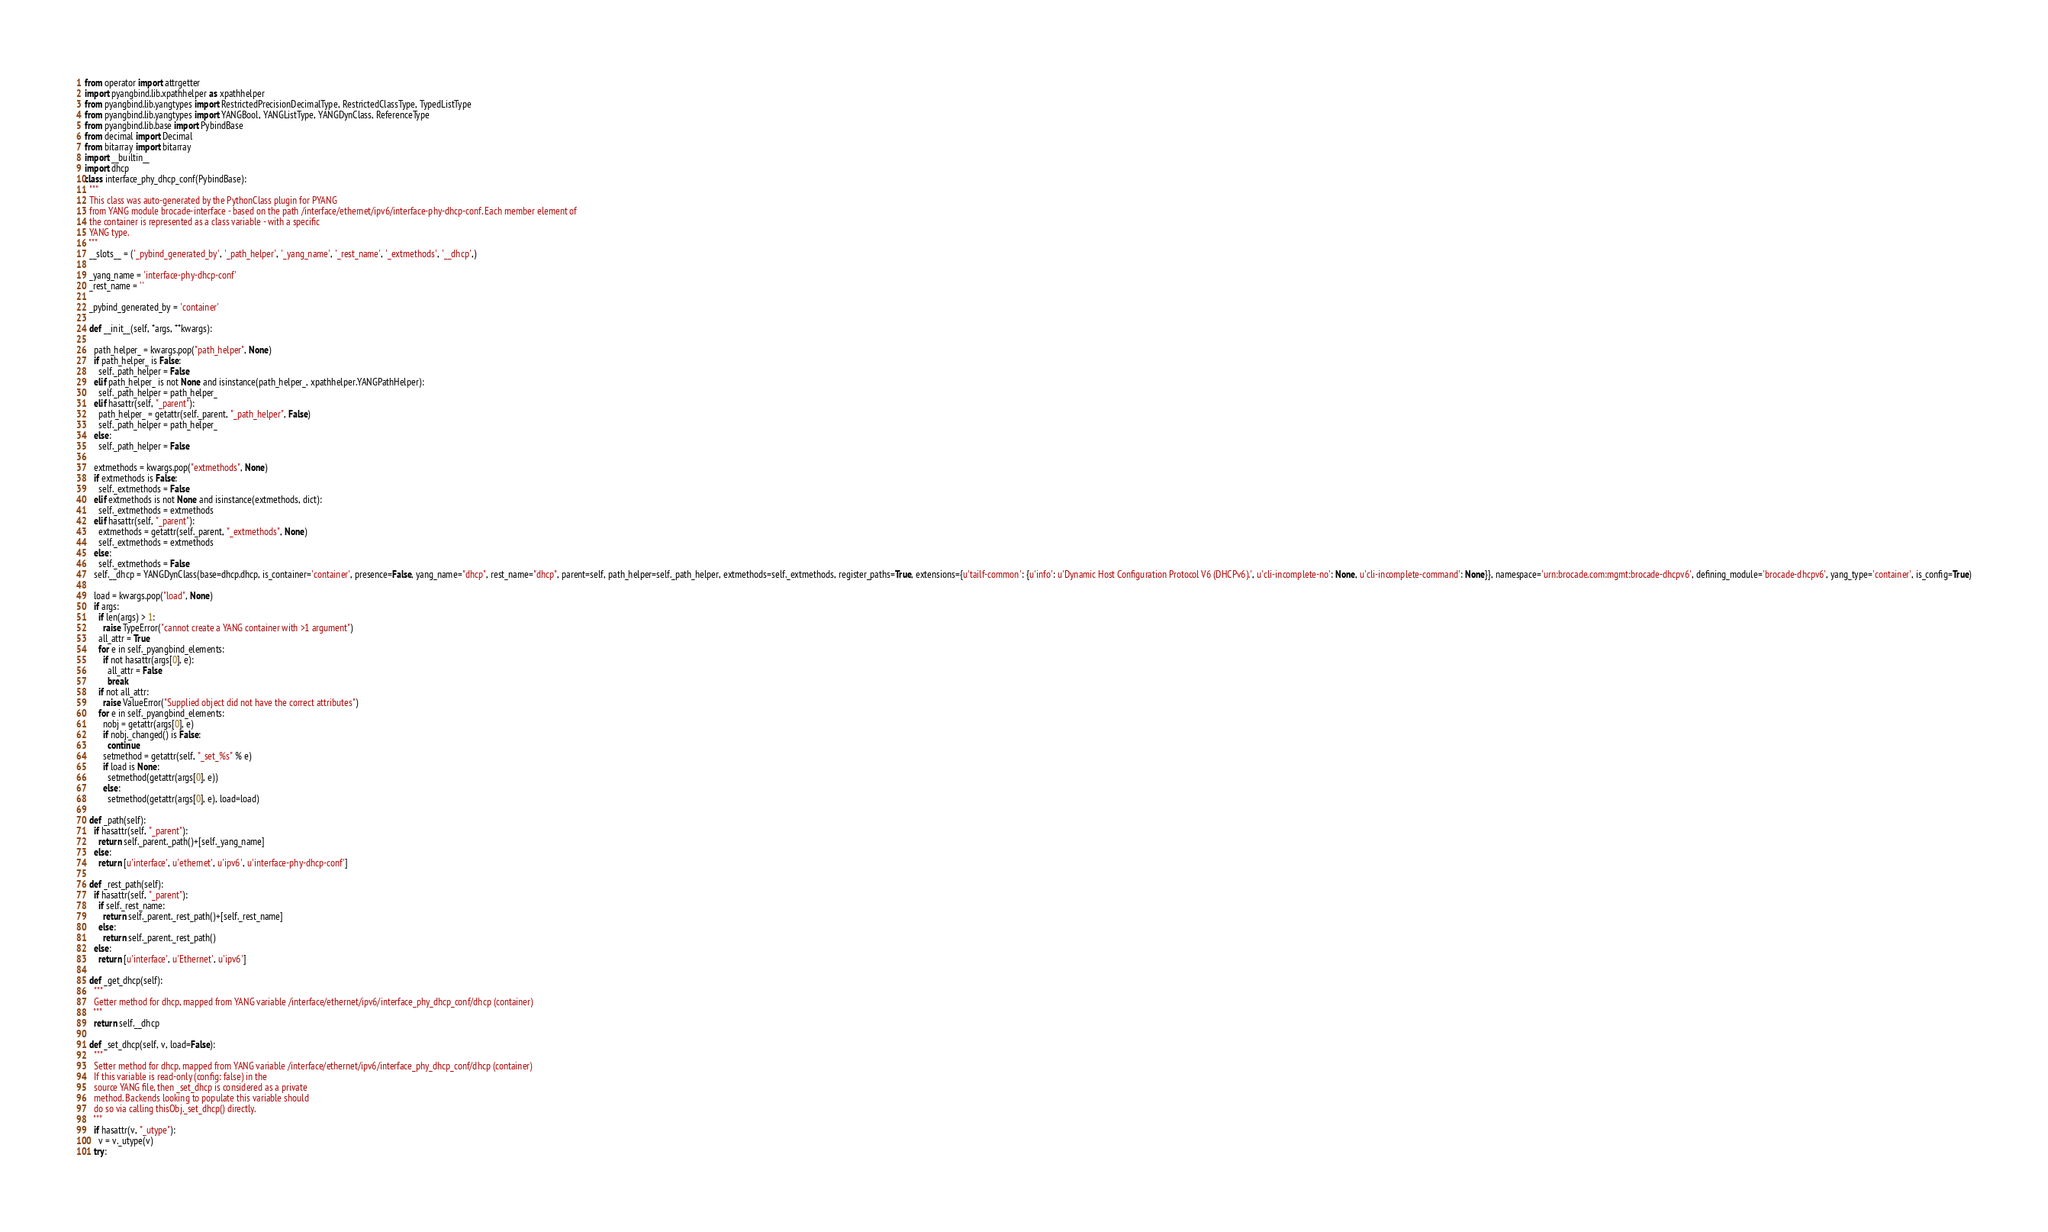Convert code to text. <code><loc_0><loc_0><loc_500><loc_500><_Python_>
from operator import attrgetter
import pyangbind.lib.xpathhelper as xpathhelper
from pyangbind.lib.yangtypes import RestrictedPrecisionDecimalType, RestrictedClassType, TypedListType
from pyangbind.lib.yangtypes import YANGBool, YANGListType, YANGDynClass, ReferenceType
from pyangbind.lib.base import PybindBase
from decimal import Decimal
from bitarray import bitarray
import __builtin__
import dhcp
class interface_phy_dhcp_conf(PybindBase):
  """
  This class was auto-generated by the PythonClass plugin for PYANG
  from YANG module brocade-interface - based on the path /interface/ethernet/ipv6/interface-phy-dhcp-conf. Each member element of
  the container is represented as a class variable - with a specific
  YANG type.
  """
  __slots__ = ('_pybind_generated_by', '_path_helper', '_yang_name', '_rest_name', '_extmethods', '__dhcp',)

  _yang_name = 'interface-phy-dhcp-conf'
  _rest_name = ''

  _pybind_generated_by = 'container'

  def __init__(self, *args, **kwargs):

    path_helper_ = kwargs.pop("path_helper", None)
    if path_helper_ is False:
      self._path_helper = False
    elif path_helper_ is not None and isinstance(path_helper_, xpathhelper.YANGPathHelper):
      self._path_helper = path_helper_
    elif hasattr(self, "_parent"):
      path_helper_ = getattr(self._parent, "_path_helper", False)
      self._path_helper = path_helper_
    else:
      self._path_helper = False

    extmethods = kwargs.pop("extmethods", None)
    if extmethods is False:
      self._extmethods = False
    elif extmethods is not None and isinstance(extmethods, dict):
      self._extmethods = extmethods
    elif hasattr(self, "_parent"):
      extmethods = getattr(self._parent, "_extmethods", None)
      self._extmethods = extmethods
    else:
      self._extmethods = False
    self.__dhcp = YANGDynClass(base=dhcp.dhcp, is_container='container', presence=False, yang_name="dhcp", rest_name="dhcp", parent=self, path_helper=self._path_helper, extmethods=self._extmethods, register_paths=True, extensions={u'tailf-common': {u'info': u'Dynamic Host Configuration Protocol V6 (DHCPv6).', u'cli-incomplete-no': None, u'cli-incomplete-command': None}}, namespace='urn:brocade.com:mgmt:brocade-dhcpv6', defining_module='brocade-dhcpv6', yang_type='container', is_config=True)

    load = kwargs.pop("load", None)
    if args:
      if len(args) > 1:
        raise TypeError("cannot create a YANG container with >1 argument")
      all_attr = True
      for e in self._pyangbind_elements:
        if not hasattr(args[0], e):
          all_attr = False
          break
      if not all_attr:
        raise ValueError("Supplied object did not have the correct attributes")
      for e in self._pyangbind_elements:
        nobj = getattr(args[0], e)
        if nobj._changed() is False:
          continue
        setmethod = getattr(self, "_set_%s" % e)
        if load is None:
          setmethod(getattr(args[0], e))
        else:
          setmethod(getattr(args[0], e), load=load)

  def _path(self):
    if hasattr(self, "_parent"):
      return self._parent._path()+[self._yang_name]
    else:
      return [u'interface', u'ethernet', u'ipv6', u'interface-phy-dhcp-conf']

  def _rest_path(self):
    if hasattr(self, "_parent"):
      if self._rest_name:
        return self._parent._rest_path()+[self._rest_name]
      else:
        return self._parent._rest_path()
    else:
      return [u'interface', u'Ethernet', u'ipv6']

  def _get_dhcp(self):
    """
    Getter method for dhcp, mapped from YANG variable /interface/ethernet/ipv6/interface_phy_dhcp_conf/dhcp (container)
    """
    return self.__dhcp
      
  def _set_dhcp(self, v, load=False):
    """
    Setter method for dhcp, mapped from YANG variable /interface/ethernet/ipv6/interface_phy_dhcp_conf/dhcp (container)
    If this variable is read-only (config: false) in the
    source YANG file, then _set_dhcp is considered as a private
    method. Backends looking to populate this variable should
    do so via calling thisObj._set_dhcp() directly.
    """
    if hasattr(v, "_utype"):
      v = v._utype(v)
    try:</code> 